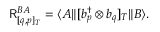<formula> <loc_0><loc_0><loc_500><loc_500>R _ { [ q , p ] _ { T } } ^ { B A } = \langle A \| [ b _ { p } ^ { \dagger } \otimes b _ { q } ] _ { T } \| B \rangle .</formula> 